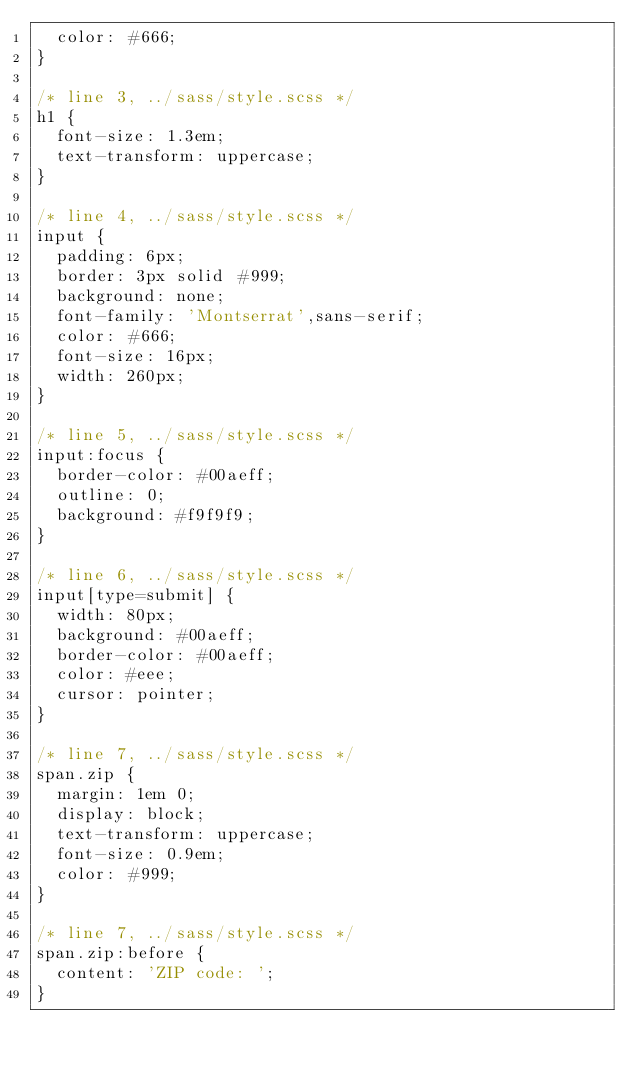<code> <loc_0><loc_0><loc_500><loc_500><_CSS_>  color: #666;
}

/* line 3, ../sass/style.scss */
h1 {
  font-size: 1.3em;
  text-transform: uppercase;
}

/* line 4, ../sass/style.scss */
input {
  padding: 6px;
  border: 3px solid #999;
  background: none;
  font-family: 'Montserrat',sans-serif;
  color: #666;
  font-size: 16px;
  width: 260px;
}

/* line 5, ../sass/style.scss */
input:focus {
  border-color: #00aeff;
  outline: 0;
  background: #f9f9f9;
}

/* line 6, ../sass/style.scss */
input[type=submit] {
  width: 80px;
  background: #00aeff;
  border-color: #00aeff;
  color: #eee;
  cursor: pointer;
}

/* line 7, ../sass/style.scss */
span.zip {
  margin: 1em 0;
  display: block;
  text-transform: uppercase;
  font-size: 0.9em;
  color: #999;
}

/* line 7, ../sass/style.scss */
span.zip:before {
  content: 'ZIP code: ';
}
</code> 